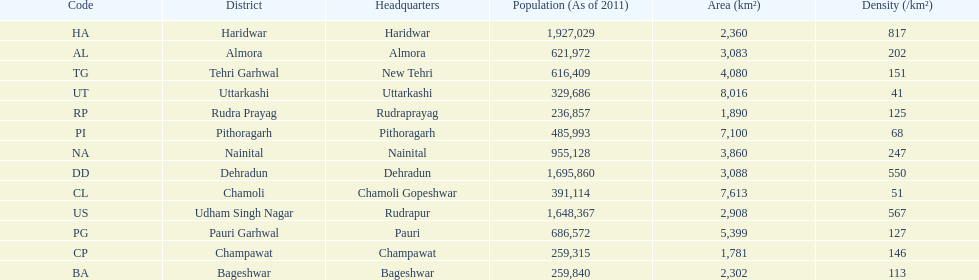Which code is above cl BA. 